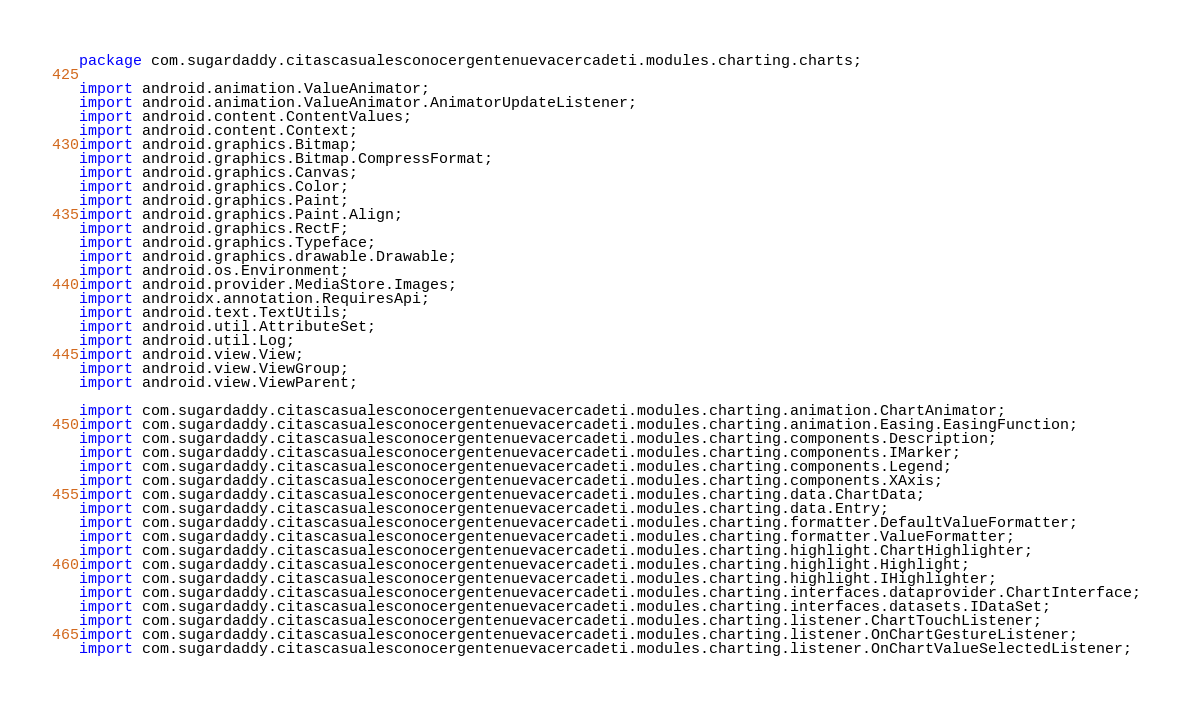Convert code to text. <code><loc_0><loc_0><loc_500><loc_500><_Java_>package com.sugardaddy.citascasualesconocergentenuevacercadeti.modules.charting.charts;

import android.animation.ValueAnimator;
import android.animation.ValueAnimator.AnimatorUpdateListener;
import android.content.ContentValues;
import android.content.Context;
import android.graphics.Bitmap;
import android.graphics.Bitmap.CompressFormat;
import android.graphics.Canvas;
import android.graphics.Color;
import android.graphics.Paint;
import android.graphics.Paint.Align;
import android.graphics.RectF;
import android.graphics.Typeface;
import android.graphics.drawable.Drawable;
import android.os.Environment;
import android.provider.MediaStore.Images;
import androidx.annotation.RequiresApi;
import android.text.TextUtils;
import android.util.AttributeSet;
import android.util.Log;
import android.view.View;
import android.view.ViewGroup;
import android.view.ViewParent;

import com.sugardaddy.citascasualesconocergentenuevacercadeti.modules.charting.animation.ChartAnimator;
import com.sugardaddy.citascasualesconocergentenuevacercadeti.modules.charting.animation.Easing.EasingFunction;
import com.sugardaddy.citascasualesconocergentenuevacercadeti.modules.charting.components.Description;
import com.sugardaddy.citascasualesconocergentenuevacercadeti.modules.charting.components.IMarker;
import com.sugardaddy.citascasualesconocergentenuevacercadeti.modules.charting.components.Legend;
import com.sugardaddy.citascasualesconocergentenuevacercadeti.modules.charting.components.XAxis;
import com.sugardaddy.citascasualesconocergentenuevacercadeti.modules.charting.data.ChartData;
import com.sugardaddy.citascasualesconocergentenuevacercadeti.modules.charting.data.Entry;
import com.sugardaddy.citascasualesconocergentenuevacercadeti.modules.charting.formatter.DefaultValueFormatter;
import com.sugardaddy.citascasualesconocergentenuevacercadeti.modules.charting.formatter.ValueFormatter;
import com.sugardaddy.citascasualesconocergentenuevacercadeti.modules.charting.highlight.ChartHighlighter;
import com.sugardaddy.citascasualesconocergentenuevacercadeti.modules.charting.highlight.Highlight;
import com.sugardaddy.citascasualesconocergentenuevacercadeti.modules.charting.highlight.IHighlighter;
import com.sugardaddy.citascasualesconocergentenuevacercadeti.modules.charting.interfaces.dataprovider.ChartInterface;
import com.sugardaddy.citascasualesconocergentenuevacercadeti.modules.charting.interfaces.datasets.IDataSet;
import com.sugardaddy.citascasualesconocergentenuevacercadeti.modules.charting.listener.ChartTouchListener;
import com.sugardaddy.citascasualesconocergentenuevacercadeti.modules.charting.listener.OnChartGestureListener;
import com.sugardaddy.citascasualesconocergentenuevacercadeti.modules.charting.listener.OnChartValueSelectedListener;</code> 